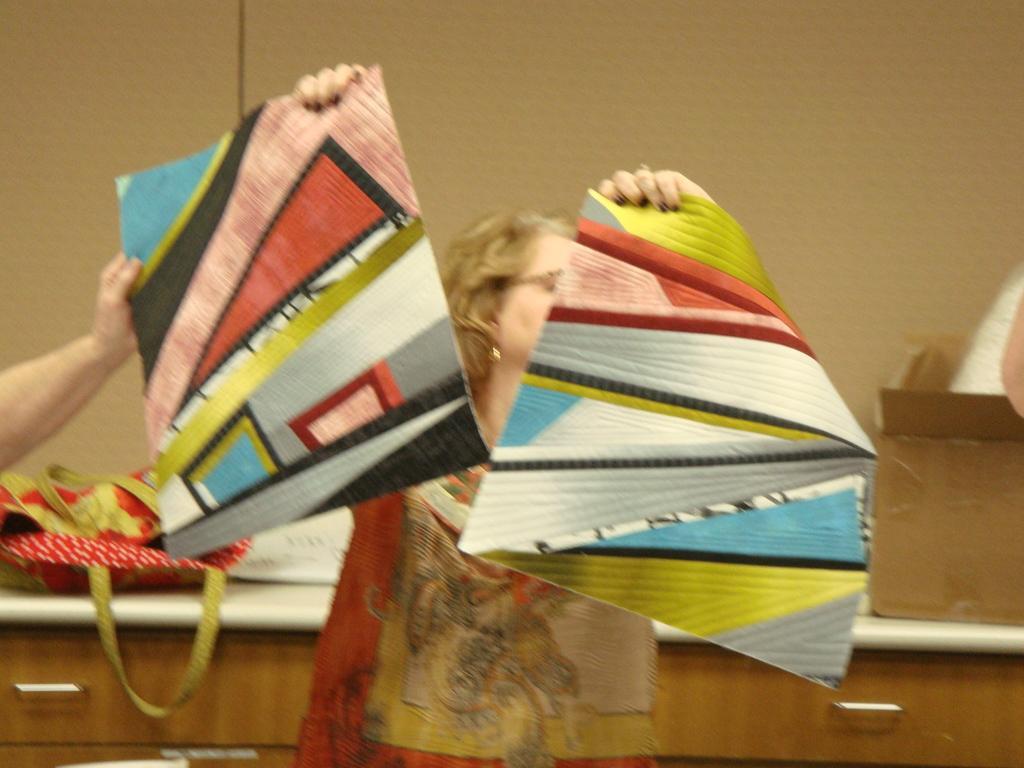Describe this image in one or two sentences. In this picture, we see the woman is holding a chart in her hands. Behind her, we see a table on which red color bag is placed. We even see the carton box is placed on the table. In the background, it is brown in color. On the left side, we see the hand of the person holding the chart. 